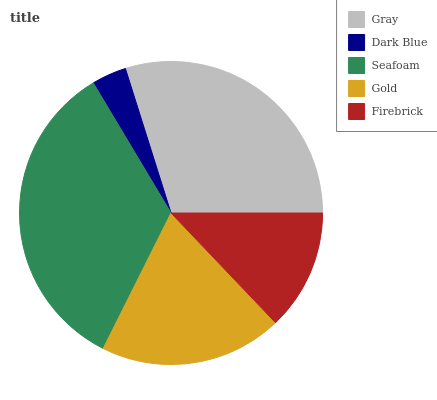Is Dark Blue the minimum?
Answer yes or no. Yes. Is Seafoam the maximum?
Answer yes or no. Yes. Is Seafoam the minimum?
Answer yes or no. No. Is Dark Blue the maximum?
Answer yes or no. No. Is Seafoam greater than Dark Blue?
Answer yes or no. Yes. Is Dark Blue less than Seafoam?
Answer yes or no. Yes. Is Dark Blue greater than Seafoam?
Answer yes or no. No. Is Seafoam less than Dark Blue?
Answer yes or no. No. Is Gold the high median?
Answer yes or no. Yes. Is Gold the low median?
Answer yes or no. Yes. Is Gray the high median?
Answer yes or no. No. Is Firebrick the low median?
Answer yes or no. No. 